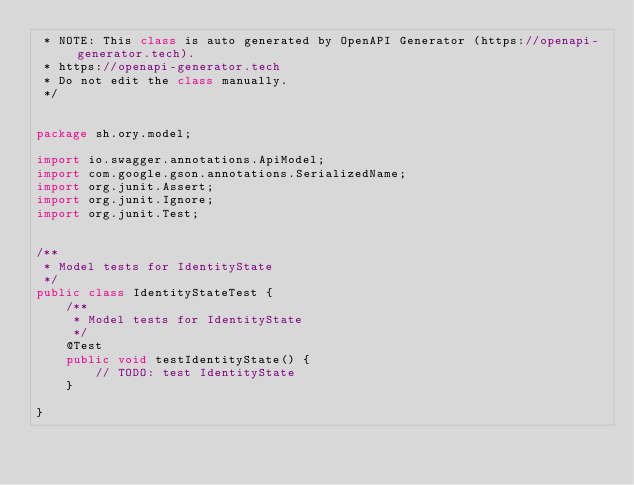<code> <loc_0><loc_0><loc_500><loc_500><_Java_> * NOTE: This class is auto generated by OpenAPI Generator (https://openapi-generator.tech).
 * https://openapi-generator.tech
 * Do not edit the class manually.
 */


package sh.ory.model;

import io.swagger.annotations.ApiModel;
import com.google.gson.annotations.SerializedName;
import org.junit.Assert;
import org.junit.Ignore;
import org.junit.Test;


/**
 * Model tests for IdentityState
 */
public class IdentityStateTest {
    /**
     * Model tests for IdentityState
     */
    @Test
    public void testIdentityState() {
        // TODO: test IdentityState
    }

}
</code> 